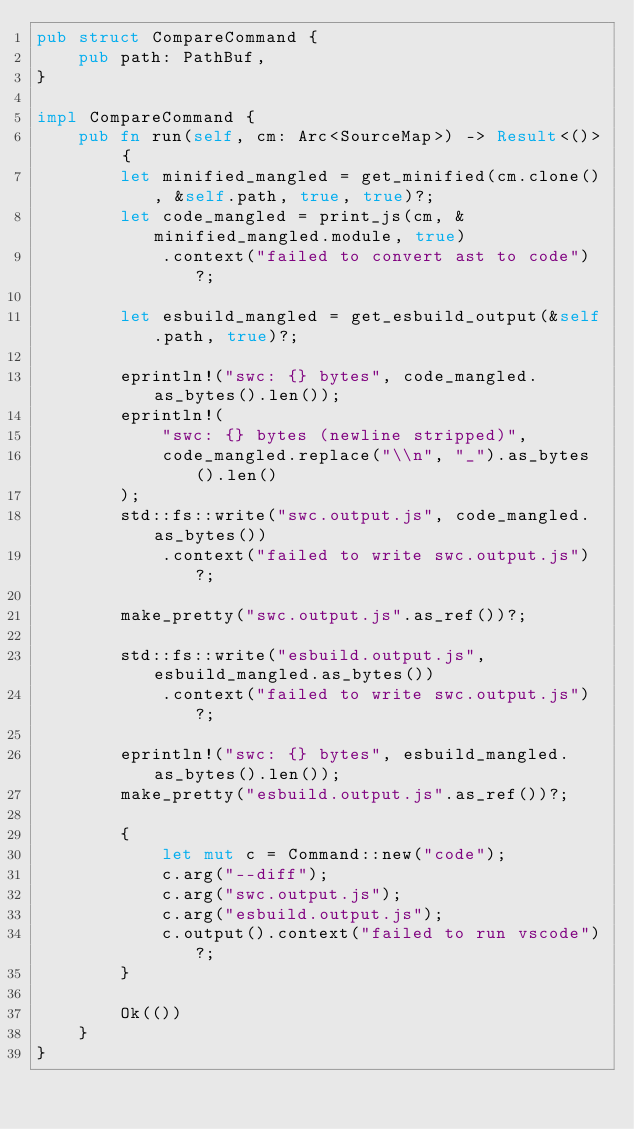<code> <loc_0><loc_0><loc_500><loc_500><_Rust_>pub struct CompareCommand {
    pub path: PathBuf,
}

impl CompareCommand {
    pub fn run(self, cm: Arc<SourceMap>) -> Result<()> {
        let minified_mangled = get_minified(cm.clone(), &self.path, true, true)?;
        let code_mangled = print_js(cm, &minified_mangled.module, true)
            .context("failed to convert ast to code")?;

        let esbuild_mangled = get_esbuild_output(&self.path, true)?;

        eprintln!("swc: {} bytes", code_mangled.as_bytes().len());
        eprintln!(
            "swc: {} bytes (newline stripped)",
            code_mangled.replace("\\n", "_").as_bytes().len()
        );
        std::fs::write("swc.output.js", code_mangled.as_bytes())
            .context("failed to write swc.output.js")?;

        make_pretty("swc.output.js".as_ref())?;

        std::fs::write("esbuild.output.js", esbuild_mangled.as_bytes())
            .context("failed to write swc.output.js")?;

        eprintln!("swc: {} bytes", esbuild_mangled.as_bytes().len());
        make_pretty("esbuild.output.js".as_ref())?;

        {
            let mut c = Command::new("code");
            c.arg("--diff");
            c.arg("swc.output.js");
            c.arg("esbuild.output.js");
            c.output().context("failed to run vscode")?;
        }

        Ok(())
    }
}
</code> 